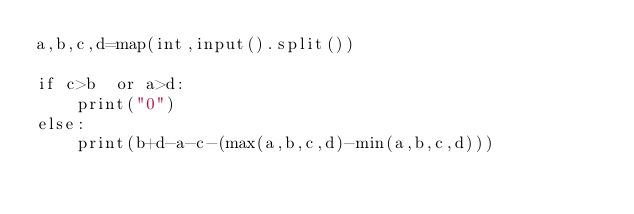Convert code to text. <code><loc_0><loc_0><loc_500><loc_500><_Python_>a,b,c,d=map(int,input().split())

if c>b  or a>d:
    print("0")
else:
    print(b+d-a-c-(max(a,b,c,d)-min(a,b,c,d)))
</code> 